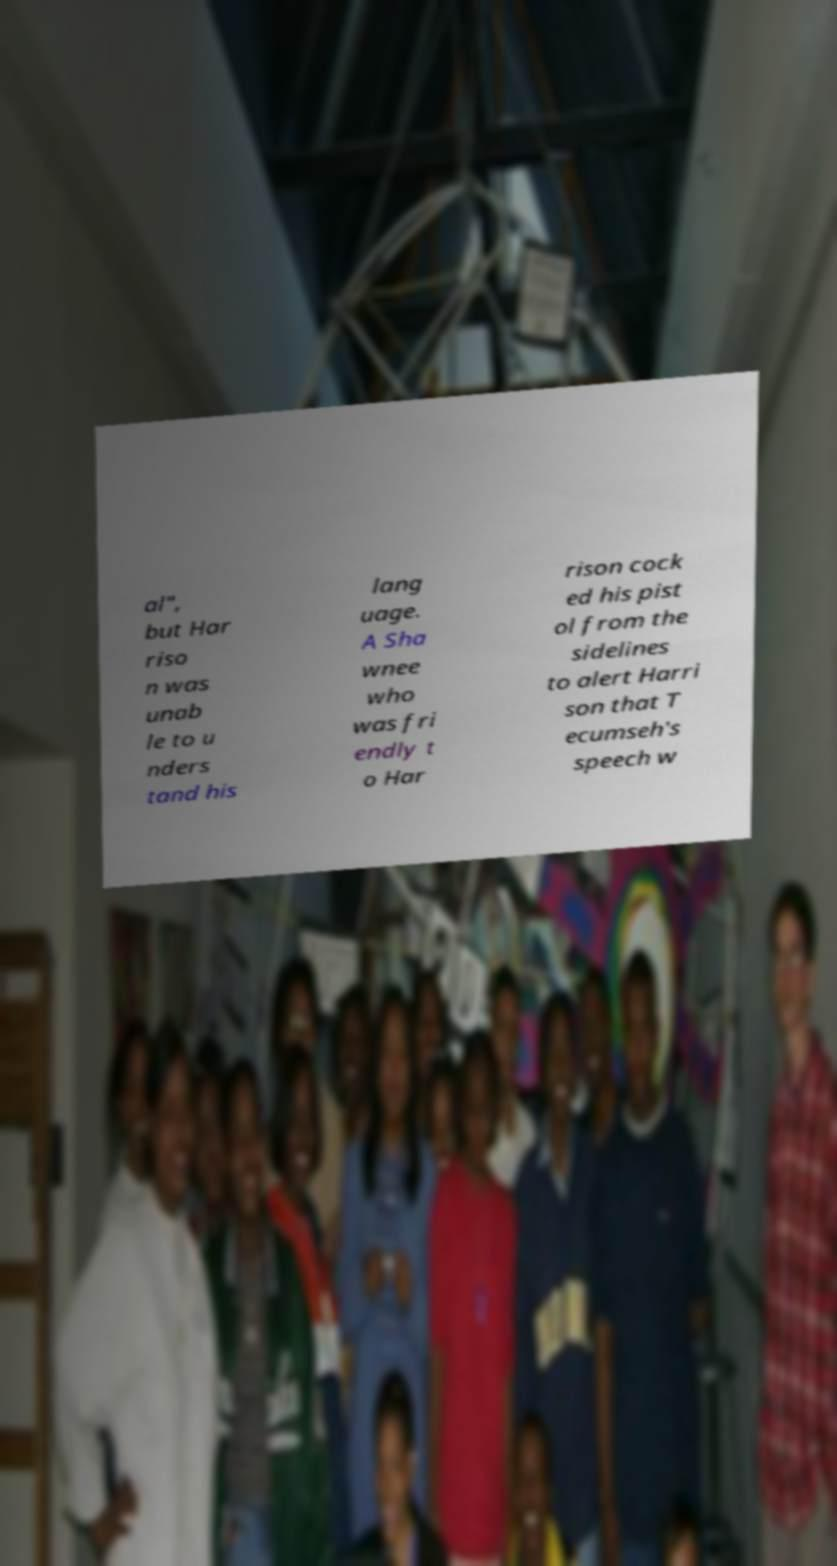Could you assist in decoding the text presented in this image and type it out clearly? al", but Har riso n was unab le to u nders tand his lang uage. A Sha wnee who was fri endly t o Har rison cock ed his pist ol from the sidelines to alert Harri son that T ecumseh's speech w 